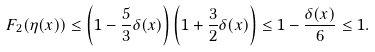<formula> <loc_0><loc_0><loc_500><loc_500>F _ { 2 } ( \eta ( x ) ) \leq \left ( 1 - \frac { 5 } { 3 } \delta ( x ) \right ) \left ( 1 + \frac { 3 } { 2 } \delta ( x ) \right ) \leq 1 - \frac { \delta ( x ) } { 6 } \leq 1 .</formula> 